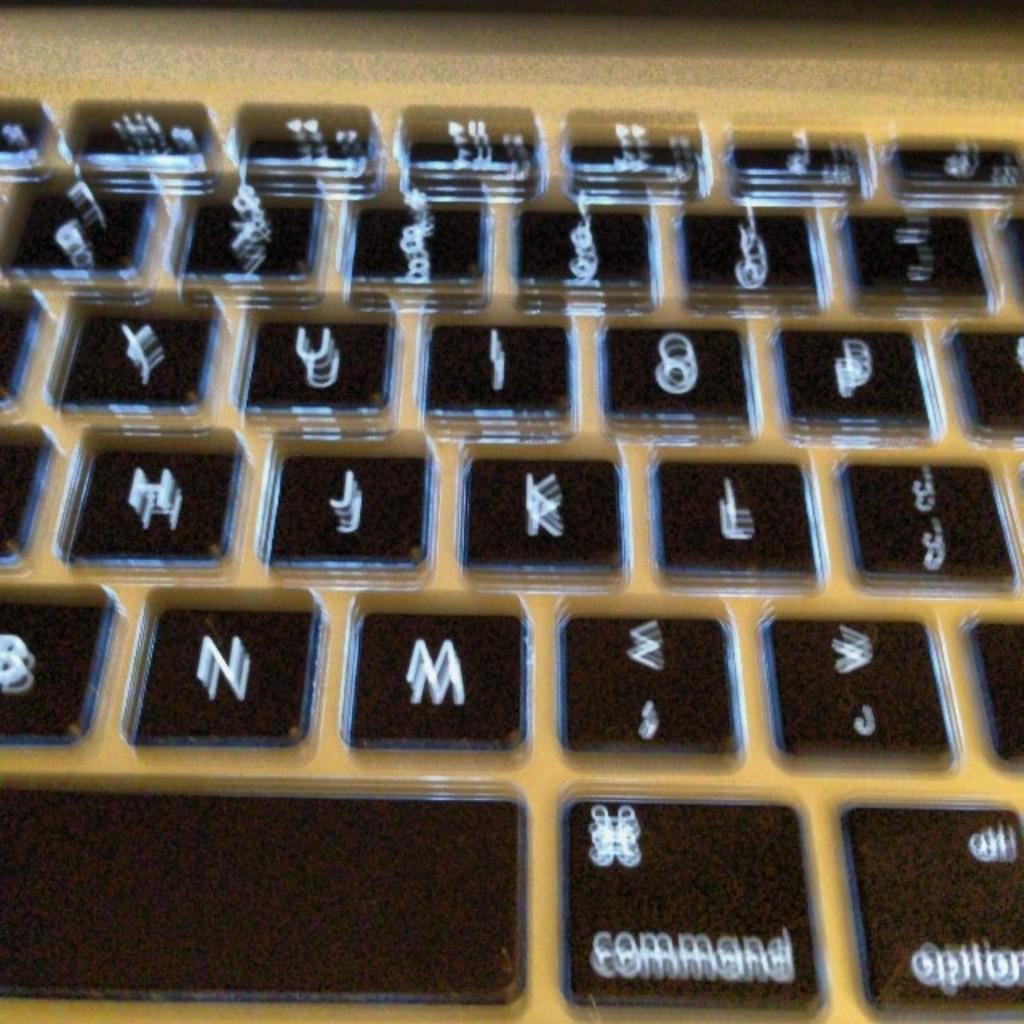How would you summarize this image in a sentence or two? In this image we can see a keyboard. 